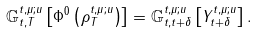<formula> <loc_0><loc_0><loc_500><loc_500>\mathbb { G } _ { t , T } ^ { t , \mu ; u } \left [ \Phi ^ { 0 } \left ( \rho _ { T } ^ { t , \mu ; u } \right ) \right ] = \mathbb { G } _ { t , t + \delta } ^ { t , \mu ; u } \left [ Y _ { t + \delta } ^ { t , \mu ; u } \right ] .</formula> 